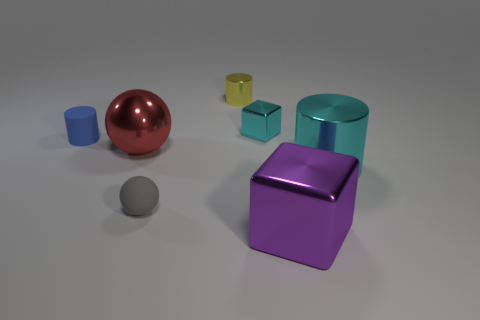Add 2 rubber spheres. How many objects exist? 9 Subtract all balls. How many objects are left? 5 Subtract all gray balls. Subtract all tiny balls. How many objects are left? 5 Add 3 metal cylinders. How many metal cylinders are left? 5 Add 5 tiny cyan rubber blocks. How many tiny cyan rubber blocks exist? 5 Subtract 1 blue cylinders. How many objects are left? 6 